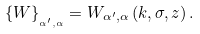Convert formula to latex. <formula><loc_0><loc_0><loc_500><loc_500>\left \{ W \right \} _ { _ { \alpha ^ { \prime } , \alpha } } = W _ { \alpha ^ { \prime } , \alpha } \left ( k , \sigma , z \right ) .</formula> 